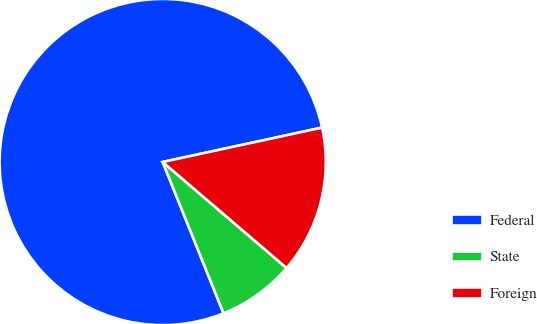<chart> <loc_0><loc_0><loc_500><loc_500><pie_chart><fcel>Federal<fcel>State<fcel>Foreign<nl><fcel>77.7%<fcel>7.65%<fcel>14.65%<nl></chart> 